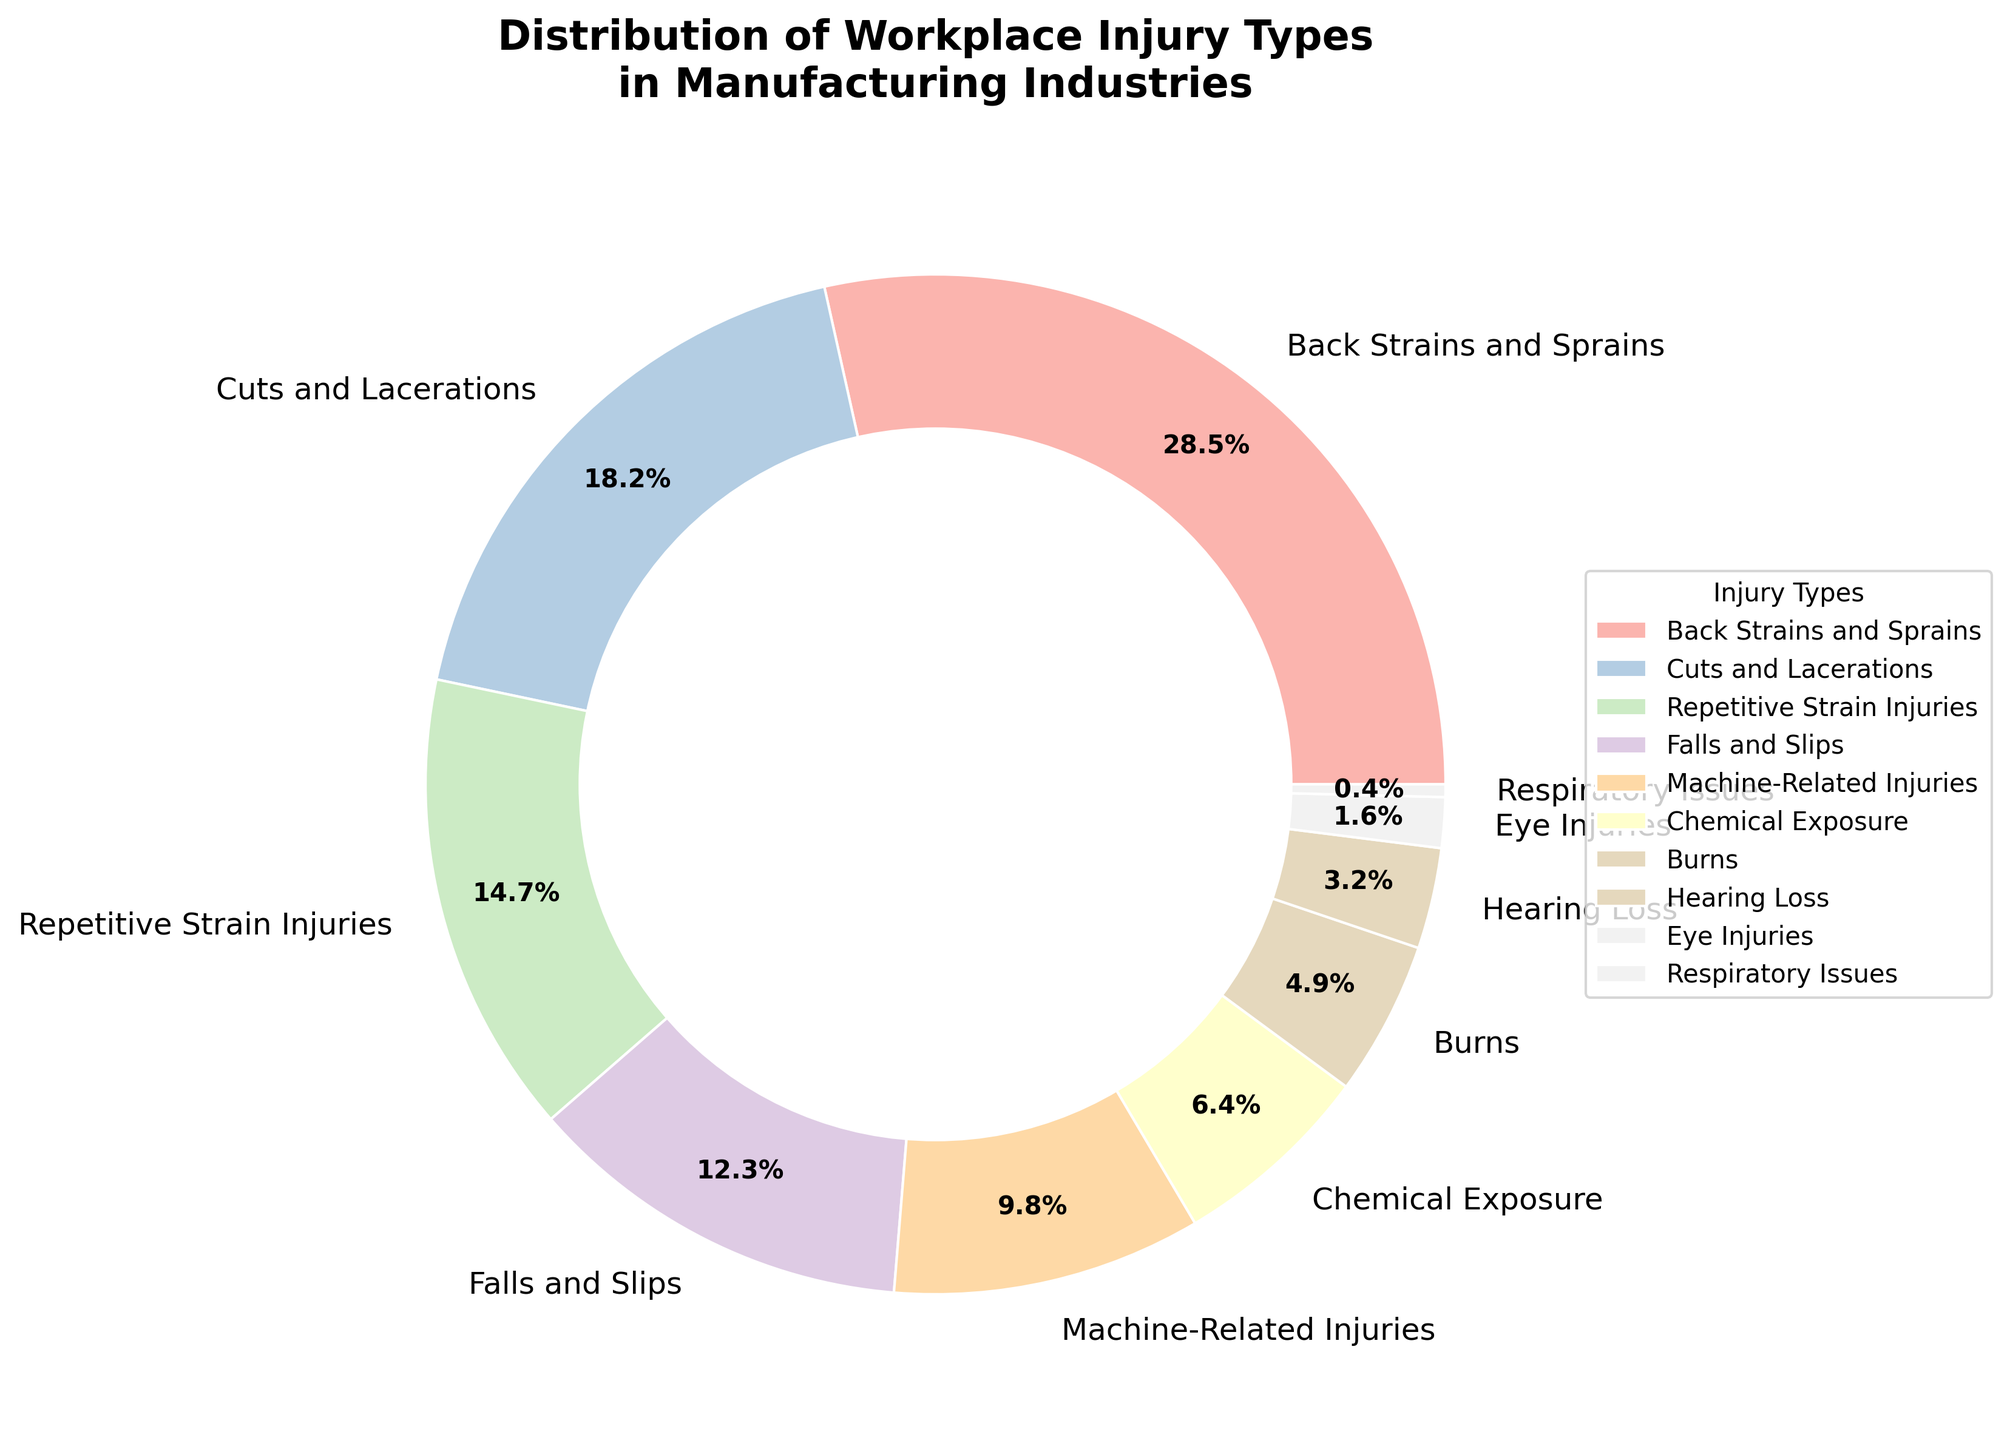Which injury type is the most common? The pie chart shows the percentage distribution of various workplace injuries in the manufacturing industry. The largest slice represents the most common injury type.
Answer: Back Strains and Sprains By what percentage are Cuts and Lacerations more common than Eye Injuries? To find this, subtract the percentage of Eye Injuries from the percentage of Cuts and Lacerations (18.2% - 1.6%).
Answer: 16.6% What is the combined percentage of Falls and Slips and Machine-Related Injuries? Sum the percentages of Falls and Slips (12.3%) and Machine-Related Injuries (9.8%).
Answer: 22.1% Are Chemical Exposure injuries more common than Burns? Compare the percentages of Chemical Exposure (6.4%) and Burns (4.9%).
Answer: Yes What proportion of the pie chart is occupied by the three least common injury types? Sum the percentages of the three least common injury types: Respiratory Issues (0.4%), Eye Injuries (1.6%), and Hearing Loss (3.2%) (0.4% + 1.6% + 3.2%).
Answer: 5.2% Is Repetitive Strain Injuries more frequent than Hearing Loss? Compare the percentages of Repetitive Strain Injuries (14.7%) and Hearing Loss (3.2%).
Answer: Yes Which injury category occupies the smallest slice, and what's its percentage? The smallest slice on the pie chart represents Respiratory Issues.
Answer: Respiratory Issues, 0.4% What is the difference in percentage between Back Strains and Sprains and Machine-Related Injuries? Subtract the percentage of Machine-Related Injuries (9.8%) from the percentage of Back Strains and Sprains (28.5%) (28.5% - 9.8%).
Answer: 18.7% If Machine-Related Injuries and Repetitive Strain Injuries are combined, what percentage of the total do they form? Sum the percentages of Machine-Related Injuries (9.8%) and Repetitive Strain Injuries (14.7%) (9.8% + 14.7%).
Answer: 24.5% Which injury type has a slightly lower percentage than Repetitive Strain Injuries? The pie chart shows Injuries sorted by percentage. The injury type just below Repetitive Strain Injuries (14.7%) is Falls and Slips (12.3%).
Answer: Falls and Slips 